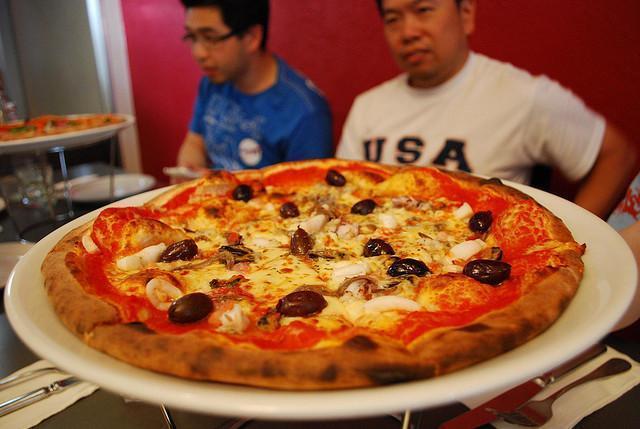How many people can be seen?
Give a very brief answer. 2. 